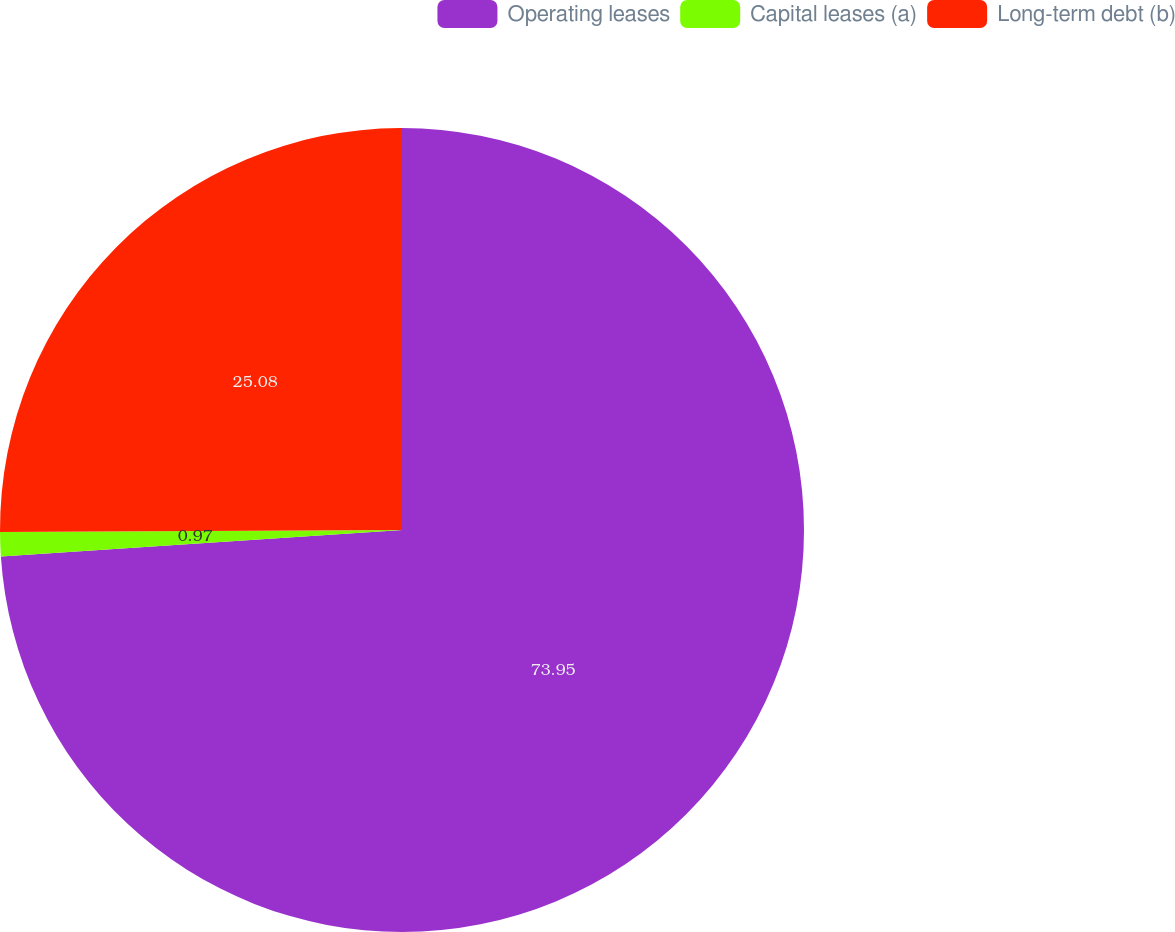Convert chart. <chart><loc_0><loc_0><loc_500><loc_500><pie_chart><fcel>Operating leases<fcel>Capital leases (a)<fcel>Long-term debt (b)<nl><fcel>73.95%<fcel>0.97%<fcel>25.08%<nl></chart> 